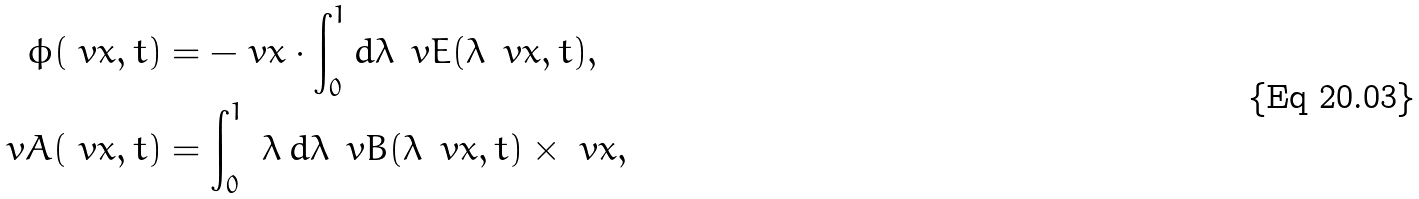Convert formula to latex. <formula><loc_0><loc_0><loc_500><loc_500>\phi ( \ v x , t ) & = - \ v x \cdot \int _ { 0 } ^ { 1 } d \lambda \, \ v E ( \lambda \, \ v x , t ) , \\ \ v A ( \ v x , t ) & = \int _ { 0 } ^ { 1 } \ \lambda \, d \lambda \, \ v B ( \lambda \, \ v x , t ) \times \ v x ,</formula> 